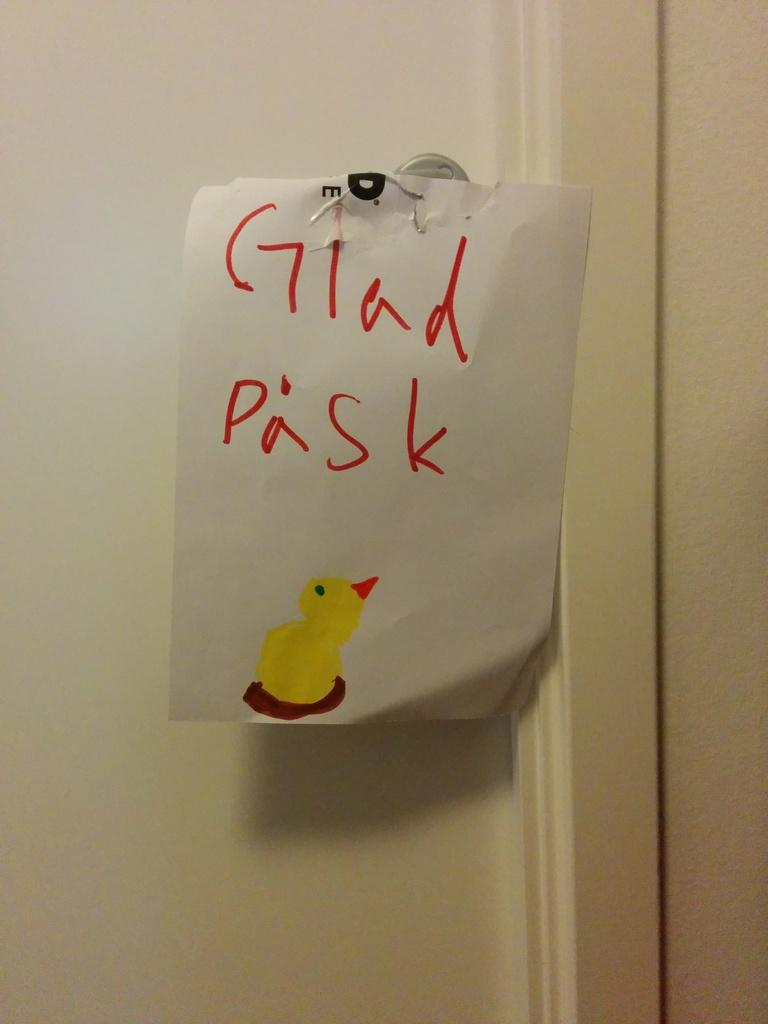What is attached to the door in the image? There is a paper with text and drawing hanging on the door. What can be found on the paper in the image? The paper has both text and a drawing on it. What type of reward is shown on the paper in the image? There is no reward shown on the paper in the image; it only has text and a drawing. What appliance is present in the image? There is no appliance present in the image; it only features a paper hanging on a door. 